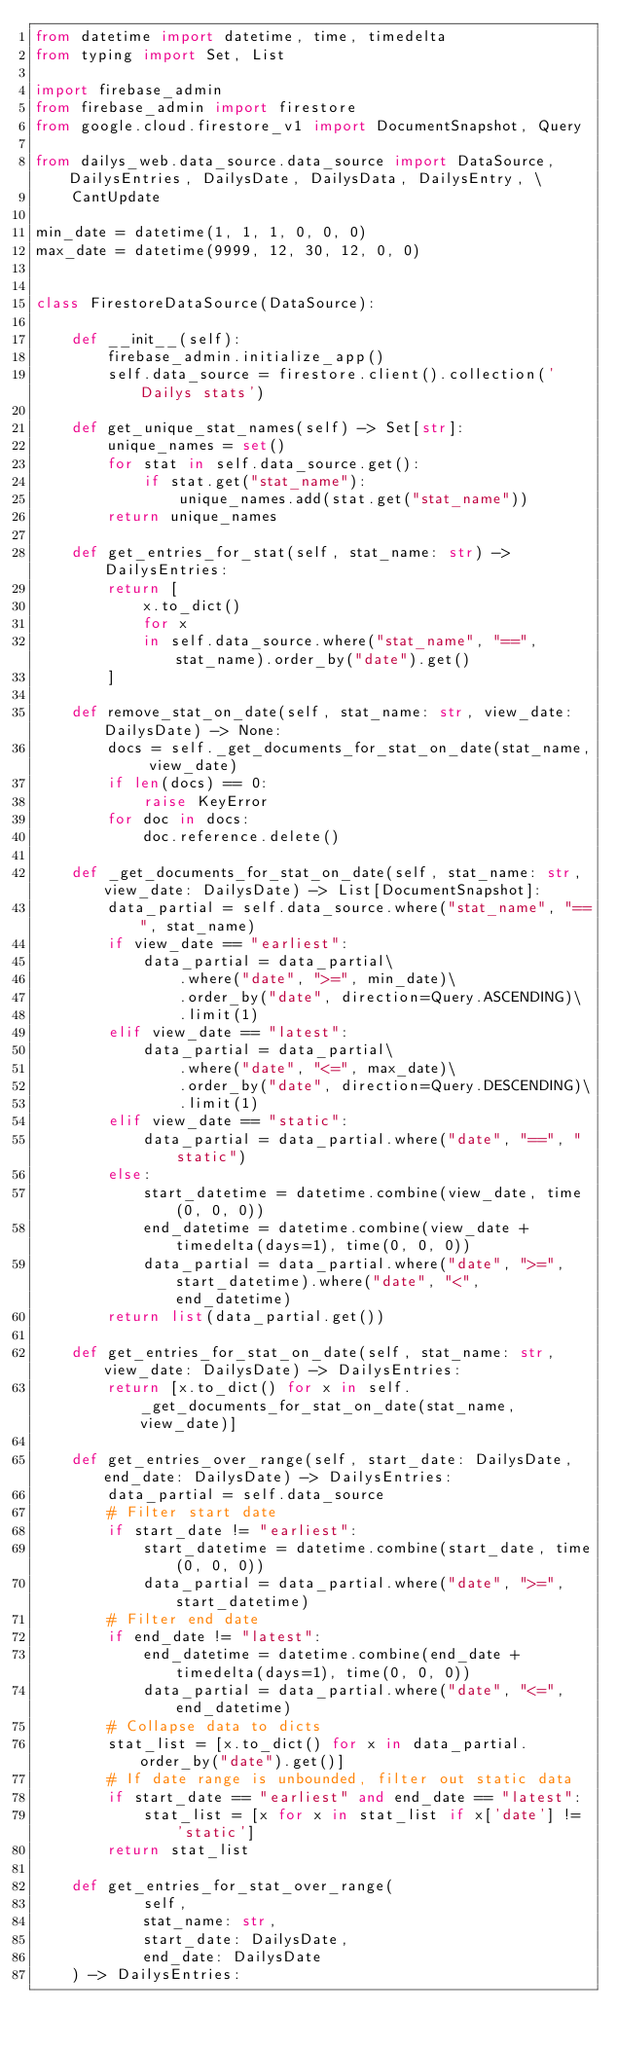<code> <loc_0><loc_0><loc_500><loc_500><_Python_>from datetime import datetime, time, timedelta
from typing import Set, List

import firebase_admin
from firebase_admin import firestore
from google.cloud.firestore_v1 import DocumentSnapshot, Query

from dailys_web.data_source.data_source import DataSource, DailysEntries, DailysDate, DailysData, DailysEntry, \
    CantUpdate

min_date = datetime(1, 1, 1, 0, 0, 0)
max_date = datetime(9999, 12, 30, 12, 0, 0)


class FirestoreDataSource(DataSource):

    def __init__(self):
        firebase_admin.initialize_app()
        self.data_source = firestore.client().collection('Dailys stats')

    def get_unique_stat_names(self) -> Set[str]:
        unique_names = set()
        for stat in self.data_source.get():
            if stat.get("stat_name"):
                unique_names.add(stat.get("stat_name"))
        return unique_names

    def get_entries_for_stat(self, stat_name: str) -> DailysEntries:
        return [
            x.to_dict()
            for x
            in self.data_source.where("stat_name", "==", stat_name).order_by("date").get()
        ]

    def remove_stat_on_date(self, stat_name: str, view_date: DailysDate) -> None:
        docs = self._get_documents_for_stat_on_date(stat_name, view_date)
        if len(docs) == 0:
            raise KeyError
        for doc in docs:
            doc.reference.delete()

    def _get_documents_for_stat_on_date(self, stat_name: str, view_date: DailysDate) -> List[DocumentSnapshot]:
        data_partial = self.data_source.where("stat_name", "==", stat_name)
        if view_date == "earliest":
            data_partial = data_partial\
                .where("date", ">=", min_date)\
                .order_by("date", direction=Query.ASCENDING)\
                .limit(1)
        elif view_date == "latest":
            data_partial = data_partial\
                .where("date", "<=", max_date)\
                .order_by("date", direction=Query.DESCENDING)\
                .limit(1)
        elif view_date == "static":
            data_partial = data_partial.where("date", "==", "static")
        else:
            start_datetime = datetime.combine(view_date, time(0, 0, 0))
            end_datetime = datetime.combine(view_date + timedelta(days=1), time(0, 0, 0))
            data_partial = data_partial.where("date", ">=", start_datetime).where("date", "<", end_datetime)
        return list(data_partial.get())

    def get_entries_for_stat_on_date(self, stat_name: str, view_date: DailysDate) -> DailysEntries:
        return [x.to_dict() for x in self._get_documents_for_stat_on_date(stat_name, view_date)]

    def get_entries_over_range(self, start_date: DailysDate, end_date: DailysDate) -> DailysEntries:
        data_partial = self.data_source
        # Filter start date
        if start_date != "earliest":
            start_datetime = datetime.combine(start_date, time(0, 0, 0))
            data_partial = data_partial.where("date", ">=", start_datetime)
        # Filter end date
        if end_date != "latest":
            end_datetime = datetime.combine(end_date + timedelta(days=1), time(0, 0, 0))
            data_partial = data_partial.where("date", "<=", end_datetime)
        # Collapse data to dicts
        stat_list = [x.to_dict() for x in data_partial.order_by("date").get()]
        # If date range is unbounded, filter out static data
        if start_date == "earliest" and end_date == "latest":
            stat_list = [x for x in stat_list if x['date'] != 'static']
        return stat_list

    def get_entries_for_stat_over_range(
            self,
            stat_name: str,
            start_date: DailysDate,
            end_date: DailysDate
    ) -> DailysEntries:</code> 